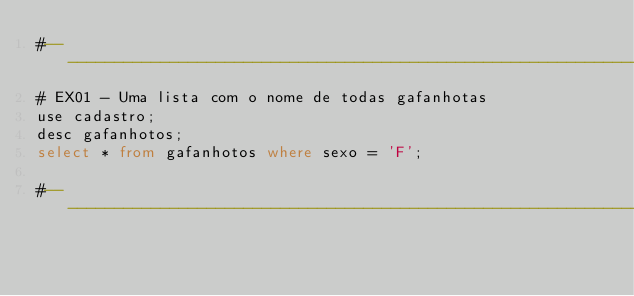<code> <loc_0><loc_0><loc_500><loc_500><_SQL_>#-------------------------------------------------------------------
# EX01 - Uma lista com o nome de todas gafanhotas
use cadastro;
desc gafanhotos;
select * from gafanhotos where sexo = 'F';

#-------------------------------------------------------------------</code> 